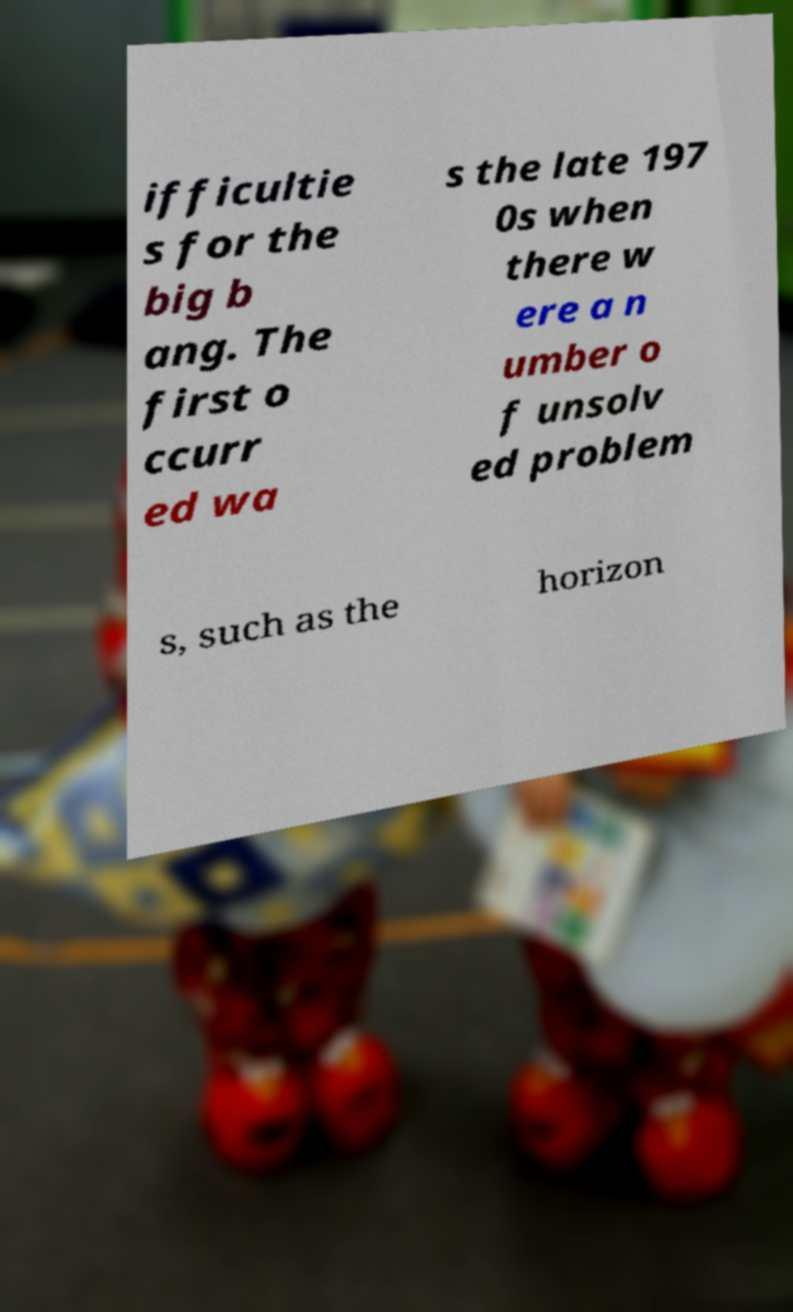I need the written content from this picture converted into text. Can you do that? ifficultie s for the big b ang. The first o ccurr ed wa s the late 197 0s when there w ere a n umber o f unsolv ed problem s, such as the horizon 